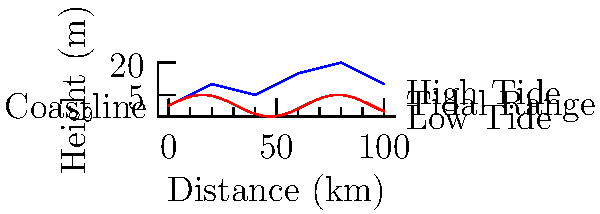As an environmental activist documenting renewable energy installations, you're tasked with estimating the tidal energy potential along a 100 km stretch of coastline. Given the coastline map and tidal range diagram above, calculate the approximate tidal energy potential in megawatts (MW) if the average tidal range is 5 meters and the energy conversion efficiency is 30%. Assume the tidal energy potential formula is:

$$ P = 0.5 \times \rho \times g \times A \times R^2 \times \eta $$

Where:
$P$ = Power potential (W)
$\rho$ = Density of seawater (1025 kg/m³)
$g$ = Gravitational acceleration (9.81 m/s²)
$A$ = Surface area of the tidal basin (m²)
$R$ = Tidal range (m)
$\eta$ = Energy conversion efficiency To solve this problem, let's follow these steps:

1. Estimate the surface area (A) of the tidal basin:
   - The coastline length is 100 km
   - Assume an average width of 2 km for the tidal basin
   - $A = 100,000 \text{ m} \times 2,000 \text{ m} = 200,000,000 \text{ m}^2$

2. Use the given values:
   - $\rho = 1025 \text{ kg/m}^3$
   - $g = 9.81 \text{ m/s}^2$
   - $R = 5 \text{ m}$
   - $\eta = 0.30$

3. Apply the formula:
   $$ P = 0.5 \times 1025 \times 9.81 \times 200,000,000 \times 5^2 \times 0.30 $$

4. Calculate:
   $$ P = 0.5 \times 1025 \times 9.81 \times 200,000,000 \times 25 \times 0.30 $$
   $$ P = 7,534,687,500 \text{ W} $$

5. Convert to megawatts:
   $$ P = 7,534.69 \text{ MW} $$

Therefore, the approximate tidal energy potential is 7,535 MW.
Answer: 7,535 MW 